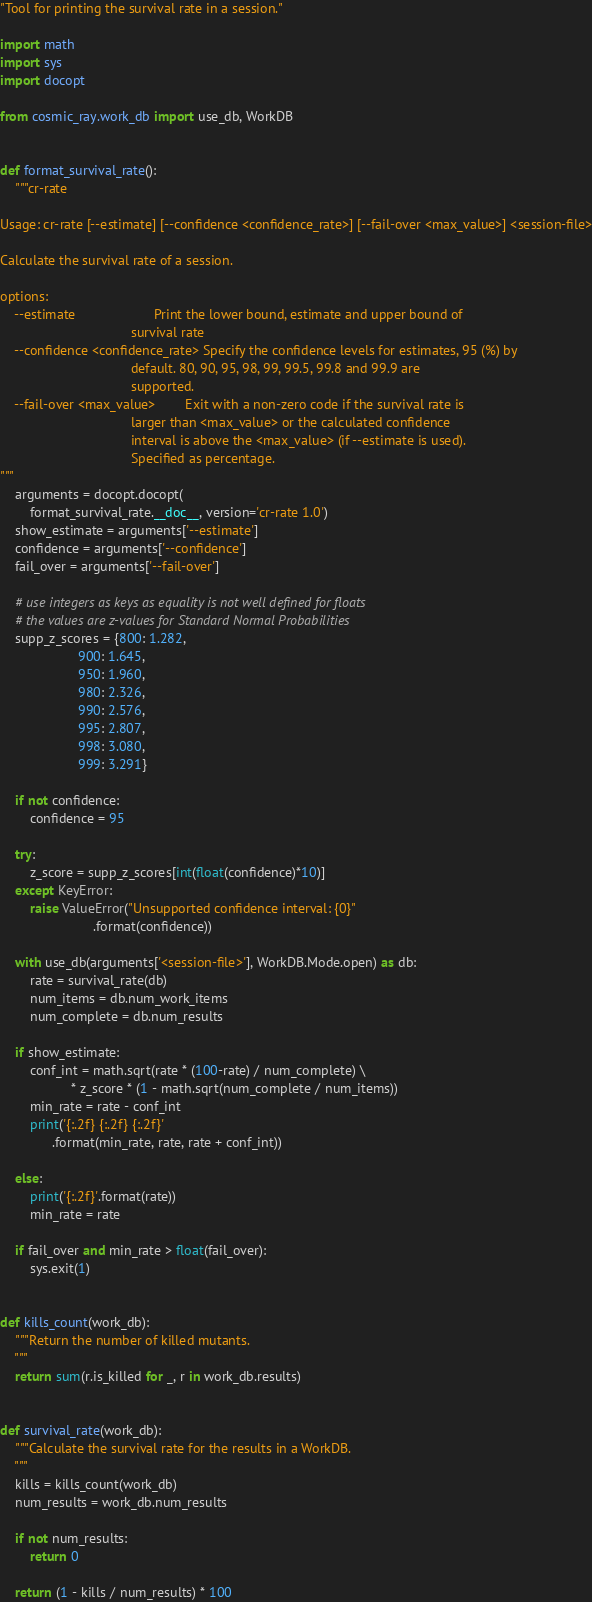<code> <loc_0><loc_0><loc_500><loc_500><_Python_>"Tool for printing the survival rate in a session."

import math
import sys
import docopt

from cosmic_ray.work_db import use_db, WorkDB


def format_survival_rate():
    """cr-rate

Usage: cr-rate [--estimate] [--confidence <confidence_rate>] [--fail-over <max_value>] <session-file>

Calculate the survival rate of a session.

options:
    --estimate                     Print the lower bound, estimate and upper bound of
                                   survival rate
    --confidence <confidence_rate> Specify the confidence levels for estimates, 95 (%) by
                                   default. 80, 90, 95, 98, 99, 99.5, 99.8 and 99.9 are
                                   supported.
    --fail-over <max_value>        Exit with a non-zero code if the survival rate is
                                   larger than <max_value> or the calculated confidence
                                   interval is above the <max_value> (if --estimate is used).
                                   Specified as percentage.
"""
    arguments = docopt.docopt(
        format_survival_rate.__doc__, version='cr-rate 1.0')
    show_estimate = arguments['--estimate']
    confidence = arguments['--confidence']
    fail_over = arguments['--fail-over']

    # use integers as keys as equality is not well defined for floats
    # the values are z-values for Standard Normal Probabilities
    supp_z_scores = {800: 1.282,
                     900: 1.645,
                     950: 1.960,
                     980: 2.326,
                     990: 2.576,
                     995: 2.807,
                     998: 3.080,
                     999: 3.291}

    if not confidence:
        confidence = 95

    try:
        z_score = supp_z_scores[int(float(confidence)*10)]
    except KeyError:
        raise ValueError("Unsupported confidence interval: {0}"
                         .format(confidence))

    with use_db(arguments['<session-file>'], WorkDB.Mode.open) as db:
        rate = survival_rate(db)
        num_items = db.num_work_items
        num_complete = db.num_results

    if show_estimate:
        conf_int = math.sqrt(rate * (100-rate) / num_complete) \
                   * z_score * (1 - math.sqrt(num_complete / num_items))
        min_rate = rate - conf_int
        print('{:.2f} {:.2f} {:.2f}'
              .format(min_rate, rate, rate + conf_int))

    else:
        print('{:.2f}'.format(rate))
        min_rate = rate

    if fail_over and min_rate > float(fail_over):
        sys.exit(1)


def kills_count(work_db):
    """Return the number of killed mutants.
    """
    return sum(r.is_killed for _, r in work_db.results)


def survival_rate(work_db):
    """Calculate the survival rate for the results in a WorkDB.
    """
    kills = kills_count(work_db)
    num_results = work_db.num_results

    if not num_results:
        return 0

    return (1 - kills / num_results) * 100
</code> 